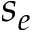<formula> <loc_0><loc_0><loc_500><loc_500>s _ { e }</formula> 